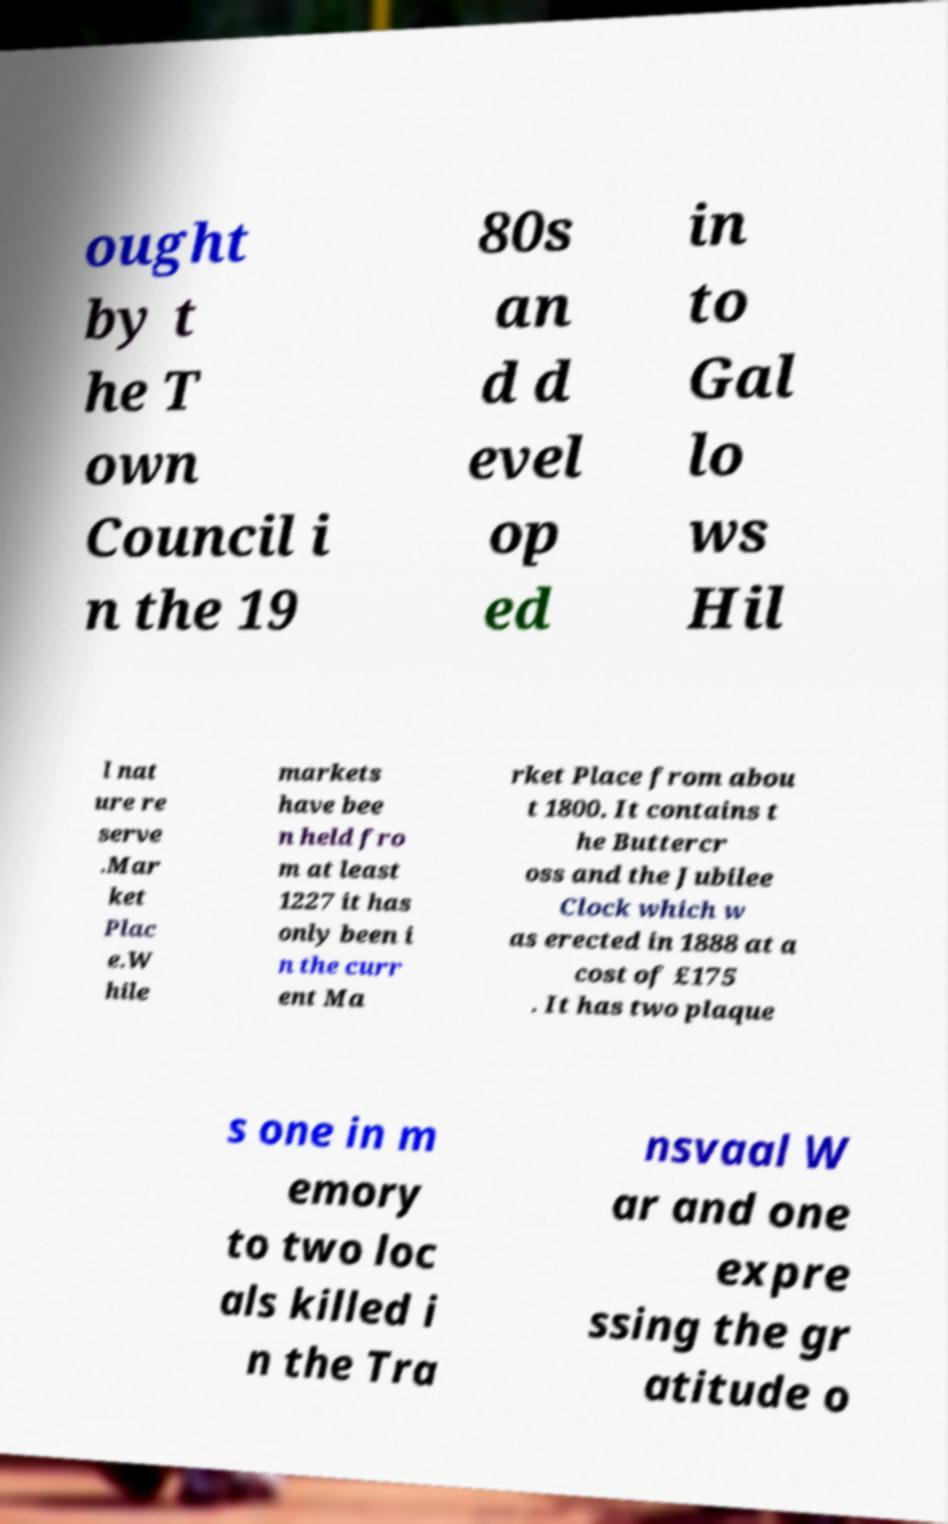Please identify and transcribe the text found in this image. ought by t he T own Council i n the 19 80s an d d evel op ed in to Gal lo ws Hil l nat ure re serve .Mar ket Plac e.W hile markets have bee n held fro m at least 1227 it has only been i n the curr ent Ma rket Place from abou t 1800. It contains t he Buttercr oss and the Jubilee Clock which w as erected in 1888 at a cost of £175 . It has two plaque s one in m emory to two loc als killed i n the Tra nsvaal W ar and one expre ssing the gr atitude o 